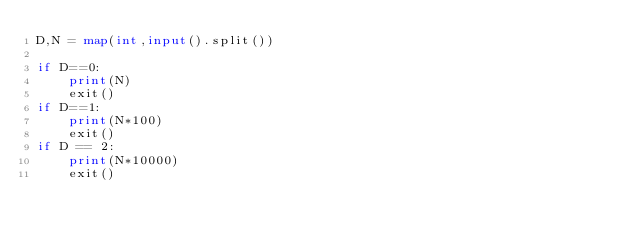<code> <loc_0><loc_0><loc_500><loc_500><_Python_>D,N = map(int,input().split())

if D==0:
    print(N)
    exit()
if D==1:
    print(N*100)
    exit()
if D == 2:
    print(N*10000)
    exit()</code> 